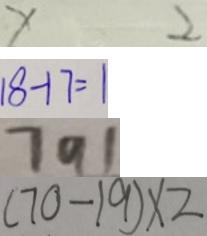Convert formula to latex. <formula><loc_0><loc_0><loc_500><loc_500>x 2 
 1 8 - 1 7 = 1 
 7 9 1 
 ( 7 0 - 1 9 ) \times 2</formula> 